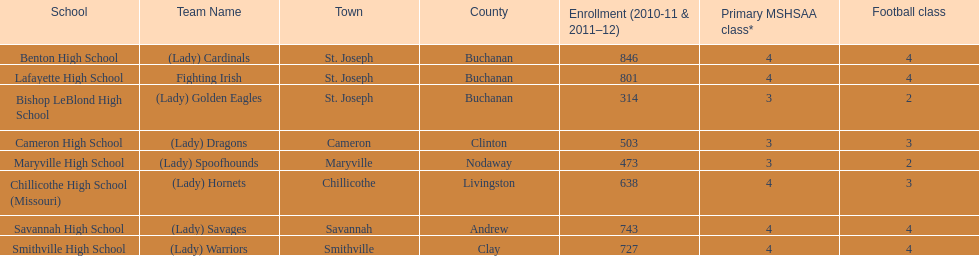What school has 3 football classes but only has 638 student enrollment? Chillicothe High School (Missouri). 